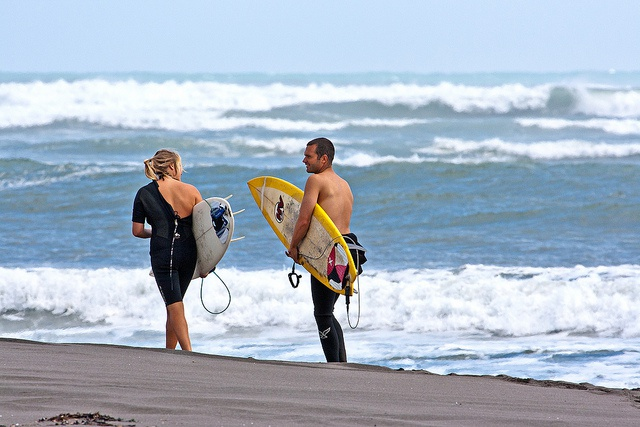Describe the objects in this image and their specific colors. I can see people in lightblue, black, brown, maroon, and gray tones, people in lightblue, black, brown, salmon, and maroon tones, surfboard in lightblue, tan, darkgray, olive, and gray tones, and surfboard in lightblue, darkgray, gray, and black tones in this image. 